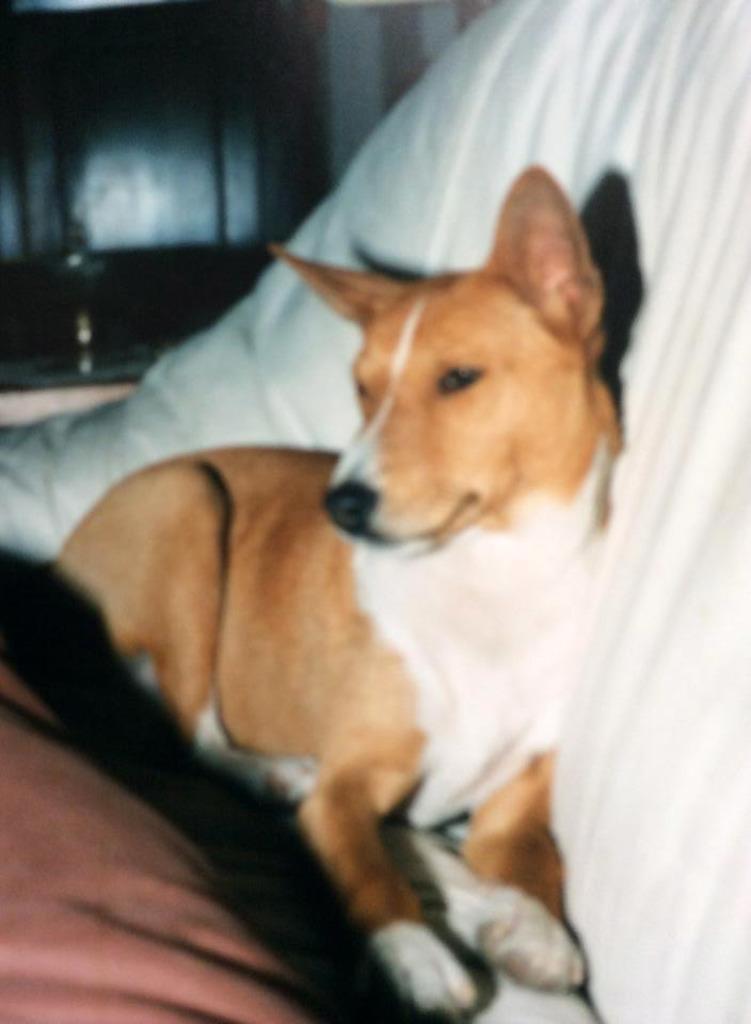Can you describe this image briefly? In this image we can see dog on the sofa. 